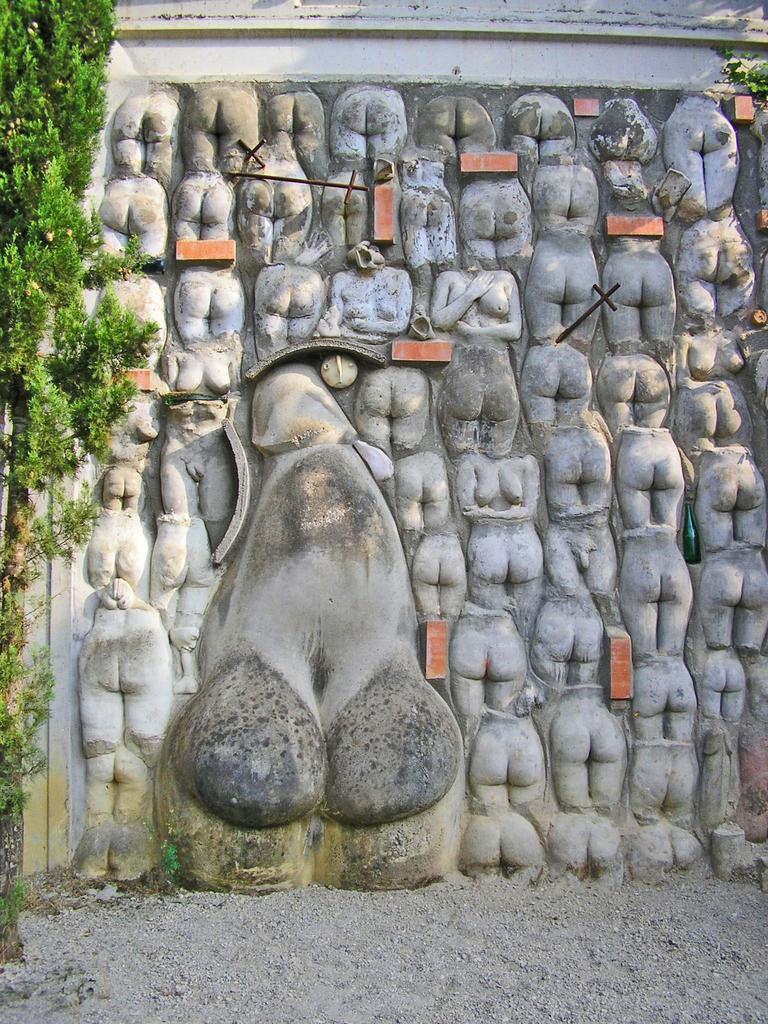What is the main subject of the image? There is a sculpture in the image. What else can be seen in the image besides the sculpture? There are plants in the image. What is the surface on which the sculpture and plants are placed? The ground is visible in the image. What type of pain is the sculpture experiencing in the image? The sculpture is not a living being and therefore cannot experience pain. 